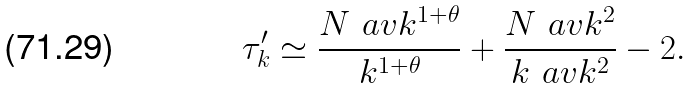Convert formula to latex. <formula><loc_0><loc_0><loc_500><loc_500>\tau _ { k } ^ { \prime } \simeq \frac { N \ a v { k ^ { 1 + \theta } } } { k ^ { 1 + \theta } } + \frac { N \ a v { k } ^ { 2 } } { k \ a v { k ^ { 2 } } } - 2 .</formula> 